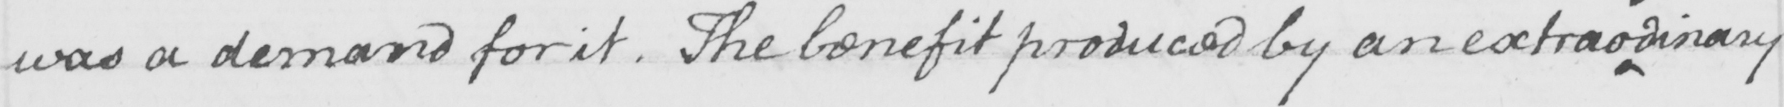What text is written in this handwritten line? was a demand for it . The benefit produced by an extrao dinary 